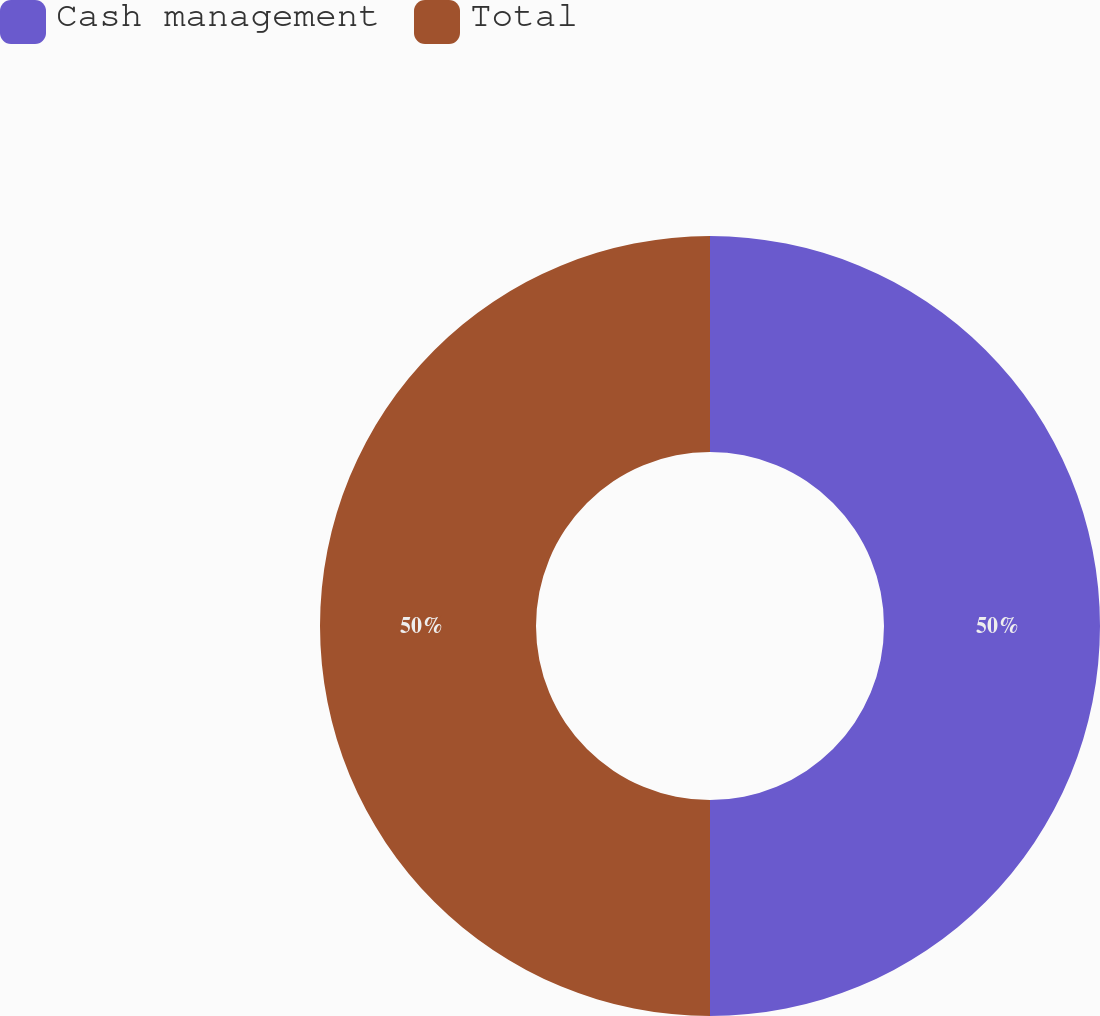<chart> <loc_0><loc_0><loc_500><loc_500><pie_chart><fcel>Cash management<fcel>Total<nl><fcel>50.0%<fcel>50.0%<nl></chart> 